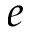Convert formula to latex. <formula><loc_0><loc_0><loc_500><loc_500>e</formula> 